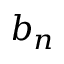<formula> <loc_0><loc_0><loc_500><loc_500>b _ { n }</formula> 